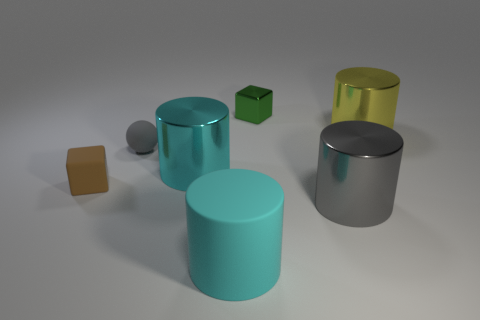Subtract all rubber cylinders. How many cylinders are left? 3 Add 2 green spheres. How many objects exist? 9 Subtract all green blocks. How many blocks are left? 1 Subtract all cubes. How many objects are left? 5 Subtract 1 blocks. How many blocks are left? 1 Subtract all green cylinders. Subtract all purple cubes. How many cylinders are left? 4 Subtract all purple balls. How many purple blocks are left? 0 Subtract all small gray rubber things. Subtract all gray balls. How many objects are left? 5 Add 7 big cyan things. How many big cyan things are left? 9 Add 6 yellow shiny cubes. How many yellow shiny cubes exist? 6 